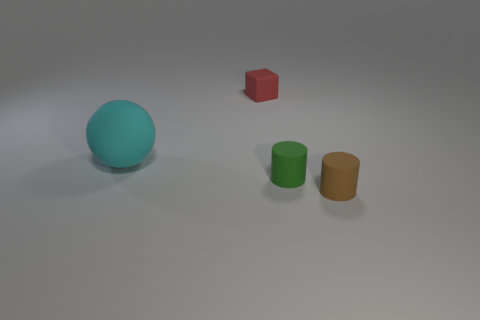There is a thing that is behind the thing that is left of the rubber object behind the large rubber ball; what color is it?
Make the answer very short. Red. Do the object left of the red matte block and the small green thing have the same material?
Keep it short and to the point. Yes. How many other objects are there of the same material as the cyan sphere?
Provide a succinct answer. 3. What is the material of the red block that is the same size as the green cylinder?
Your response must be concise. Rubber. There is a small thing that is behind the cyan rubber ball; does it have the same shape as the matte thing that is left of the small red object?
Offer a very short reply. No. There is a red matte object that is the same size as the brown matte object; what shape is it?
Ensure brevity in your answer.  Cube. Are the object on the left side of the red matte cube and the thing behind the large cyan sphere made of the same material?
Your answer should be very brief. Yes. There is a small rubber cylinder behind the tiny brown matte object; is there a brown matte cylinder behind it?
Ensure brevity in your answer.  No. There is a big object that is the same material as the cube; what is its color?
Give a very brief answer. Cyan. Is the number of gray spheres greater than the number of brown things?
Your answer should be very brief. No. 